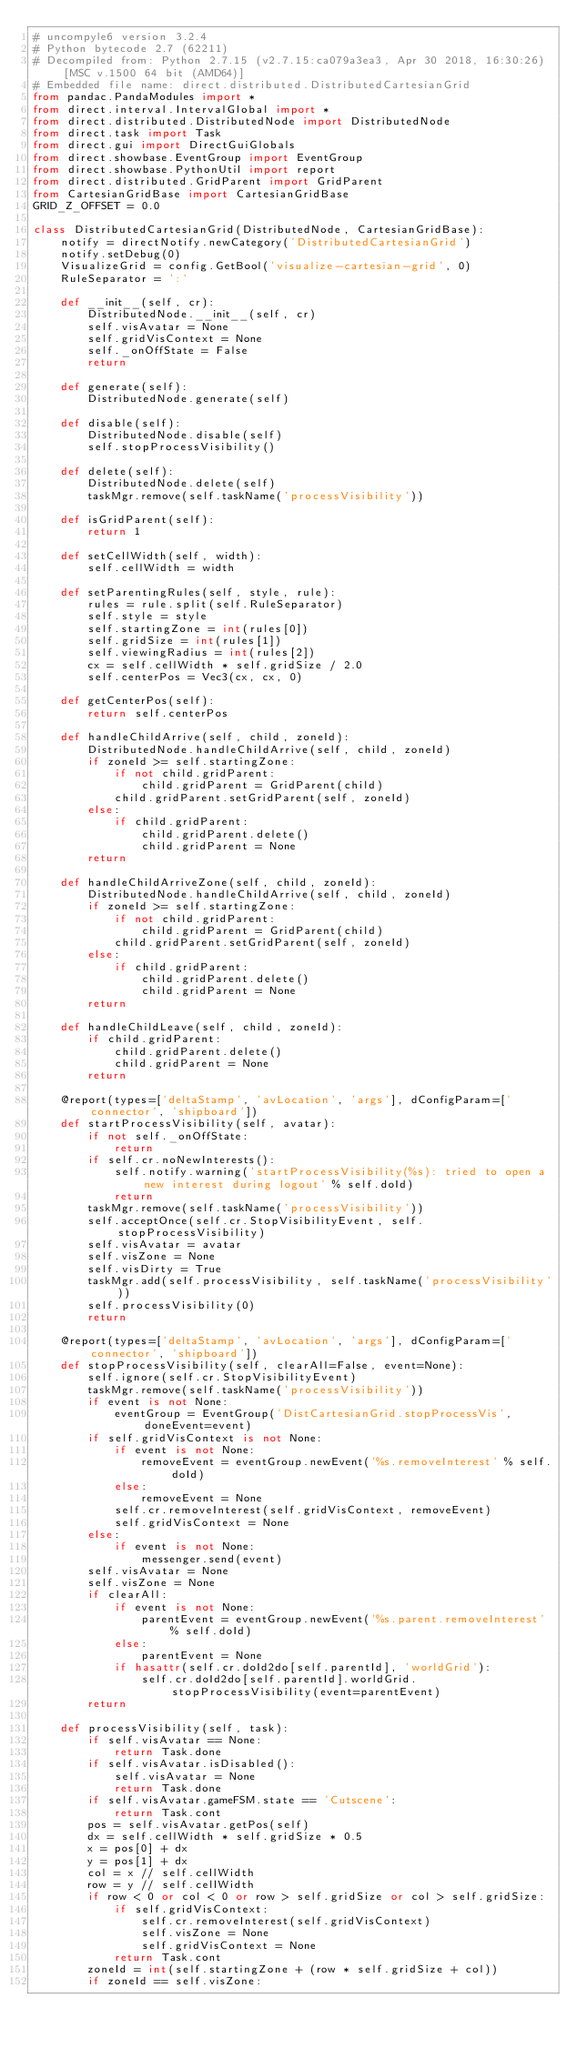Convert code to text. <code><loc_0><loc_0><loc_500><loc_500><_Python_># uncompyle6 version 3.2.4
# Python bytecode 2.7 (62211)
# Decompiled from: Python 2.7.15 (v2.7.15:ca079a3ea3, Apr 30 2018, 16:30:26) [MSC v.1500 64 bit (AMD64)]
# Embedded file name: direct.distributed.DistributedCartesianGrid
from pandac.PandaModules import *
from direct.interval.IntervalGlobal import *
from direct.distributed.DistributedNode import DistributedNode
from direct.task import Task
from direct.gui import DirectGuiGlobals
from direct.showbase.EventGroup import EventGroup
from direct.showbase.PythonUtil import report
from direct.distributed.GridParent import GridParent
from CartesianGridBase import CartesianGridBase
GRID_Z_OFFSET = 0.0

class DistributedCartesianGrid(DistributedNode, CartesianGridBase):
    notify = directNotify.newCategory('DistributedCartesianGrid')
    notify.setDebug(0)
    VisualizeGrid = config.GetBool('visualize-cartesian-grid', 0)
    RuleSeparator = ':'

    def __init__(self, cr):
        DistributedNode.__init__(self, cr)
        self.visAvatar = None
        self.gridVisContext = None
        self._onOffState = False
        return

    def generate(self):
        DistributedNode.generate(self)

    def disable(self):
        DistributedNode.disable(self)
        self.stopProcessVisibility()

    def delete(self):
        DistributedNode.delete(self)
        taskMgr.remove(self.taskName('processVisibility'))

    def isGridParent(self):
        return 1

    def setCellWidth(self, width):
        self.cellWidth = width

    def setParentingRules(self, style, rule):
        rules = rule.split(self.RuleSeparator)
        self.style = style
        self.startingZone = int(rules[0])
        self.gridSize = int(rules[1])
        self.viewingRadius = int(rules[2])
        cx = self.cellWidth * self.gridSize / 2.0
        self.centerPos = Vec3(cx, cx, 0)

    def getCenterPos(self):
        return self.centerPos

    def handleChildArrive(self, child, zoneId):
        DistributedNode.handleChildArrive(self, child, zoneId)
        if zoneId >= self.startingZone:
            if not child.gridParent:
                child.gridParent = GridParent(child)
            child.gridParent.setGridParent(self, zoneId)
        else:
            if child.gridParent:
                child.gridParent.delete()
                child.gridParent = None
        return

    def handleChildArriveZone(self, child, zoneId):
        DistributedNode.handleChildArrive(self, child, zoneId)
        if zoneId >= self.startingZone:
            if not child.gridParent:
                child.gridParent = GridParent(child)
            child.gridParent.setGridParent(self, zoneId)
        else:
            if child.gridParent:
                child.gridParent.delete()
                child.gridParent = None
        return

    def handleChildLeave(self, child, zoneId):
        if child.gridParent:
            child.gridParent.delete()
            child.gridParent = None
        return

    @report(types=['deltaStamp', 'avLocation', 'args'], dConfigParam=['connector', 'shipboard'])
    def startProcessVisibility(self, avatar):
        if not self._onOffState:
            return
        if self.cr.noNewInterests():
            self.notify.warning('startProcessVisibility(%s): tried to open a new interest during logout' % self.doId)
            return
        taskMgr.remove(self.taskName('processVisibility'))
        self.acceptOnce(self.cr.StopVisibilityEvent, self.stopProcessVisibility)
        self.visAvatar = avatar
        self.visZone = None
        self.visDirty = True
        taskMgr.add(self.processVisibility, self.taskName('processVisibility'))
        self.processVisibility(0)
        return

    @report(types=['deltaStamp', 'avLocation', 'args'], dConfigParam=['connector', 'shipboard'])
    def stopProcessVisibility(self, clearAll=False, event=None):
        self.ignore(self.cr.StopVisibilityEvent)
        taskMgr.remove(self.taskName('processVisibility'))
        if event is not None:
            eventGroup = EventGroup('DistCartesianGrid.stopProcessVis', doneEvent=event)
        if self.gridVisContext is not None:
            if event is not None:
                removeEvent = eventGroup.newEvent('%s.removeInterest' % self.doId)
            else:
                removeEvent = None
            self.cr.removeInterest(self.gridVisContext, removeEvent)
            self.gridVisContext = None
        else:
            if event is not None:
                messenger.send(event)
        self.visAvatar = None
        self.visZone = None
        if clearAll:
            if event is not None:
                parentEvent = eventGroup.newEvent('%s.parent.removeInterest' % self.doId)
            else:
                parentEvent = None
            if hasattr(self.cr.doId2do[self.parentId], 'worldGrid'):
                self.cr.doId2do[self.parentId].worldGrid.stopProcessVisibility(event=parentEvent)
        return

    def processVisibility(self, task):
        if self.visAvatar == None:
            return Task.done
        if self.visAvatar.isDisabled():
            self.visAvatar = None
            return Task.done
        if self.visAvatar.gameFSM.state == 'Cutscene':
            return Task.cont
        pos = self.visAvatar.getPos(self)
        dx = self.cellWidth * self.gridSize * 0.5
        x = pos[0] + dx
        y = pos[1] + dx
        col = x // self.cellWidth
        row = y // self.cellWidth
        if row < 0 or col < 0 or row > self.gridSize or col > self.gridSize:
            if self.gridVisContext:
                self.cr.removeInterest(self.gridVisContext)
                self.visZone = None
                self.gridVisContext = None
            return Task.cont
        zoneId = int(self.startingZone + (row * self.gridSize + col))
        if zoneId == self.visZone:</code> 